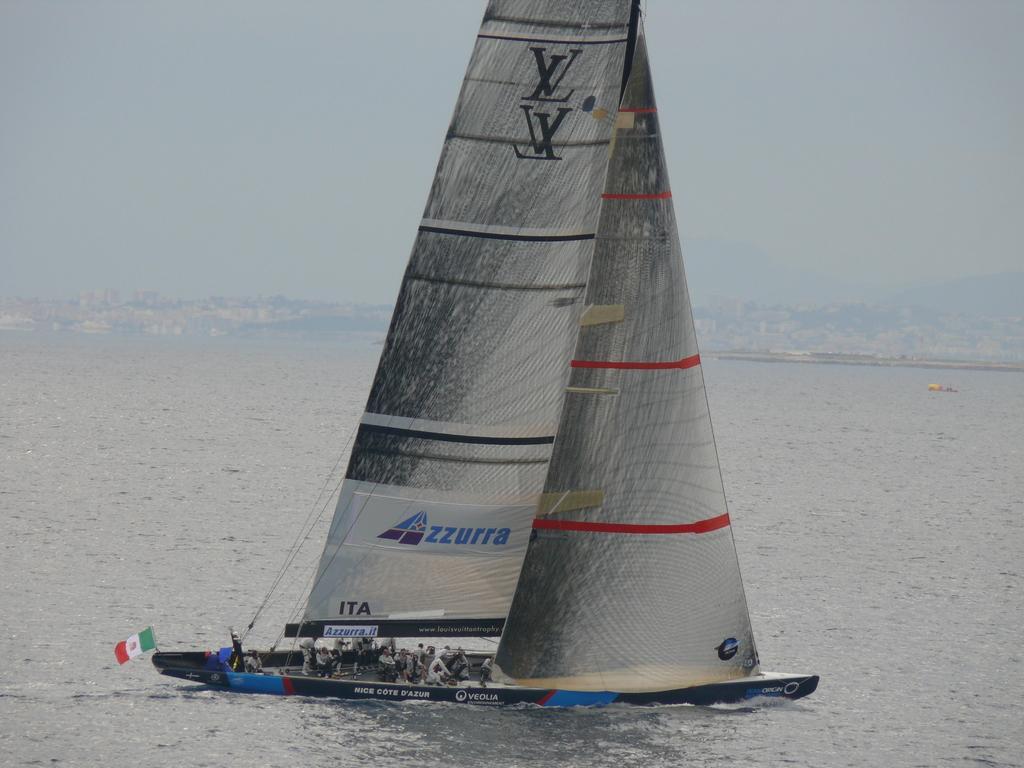How would you summarize this image in a sentence or two? In the foreground I can see a boat and a group of people. In the background I can see water, buildings, mountains and the sky. This image is taken may be near the lake during a day. 